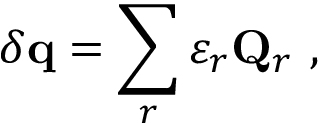<formula> <loc_0><loc_0><loc_500><loc_500>\delta q = \sum _ { r } \varepsilon _ { r } Q _ { r } ,</formula> 